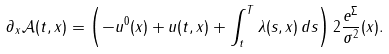<formula> <loc_0><loc_0><loc_500><loc_500>\partial _ { x } { \mathcal { A } } ( t , x ) = \left ( - u ^ { 0 } ( x ) + u ( t , x ) + \int _ { t } ^ { T } \lambda ( s , x ) \, d s \right ) 2 \frac { e ^ { \Sigma } } { \sigma ^ { 2 } } ( x ) .</formula> 